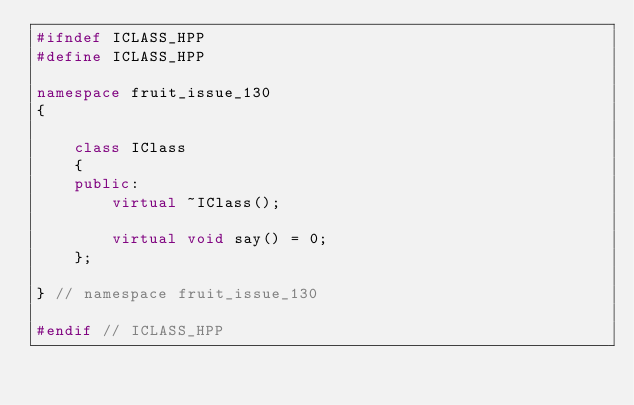Convert code to text. <code><loc_0><loc_0><loc_500><loc_500><_C++_>#ifndef ICLASS_HPP
#define ICLASS_HPP

namespace fruit_issue_130
{

    class IClass
    {
    public:
        virtual ~IClass();

        virtual void say() = 0;
    };

} // namespace fruit_issue_130

#endif // ICLASS_HPP
</code> 